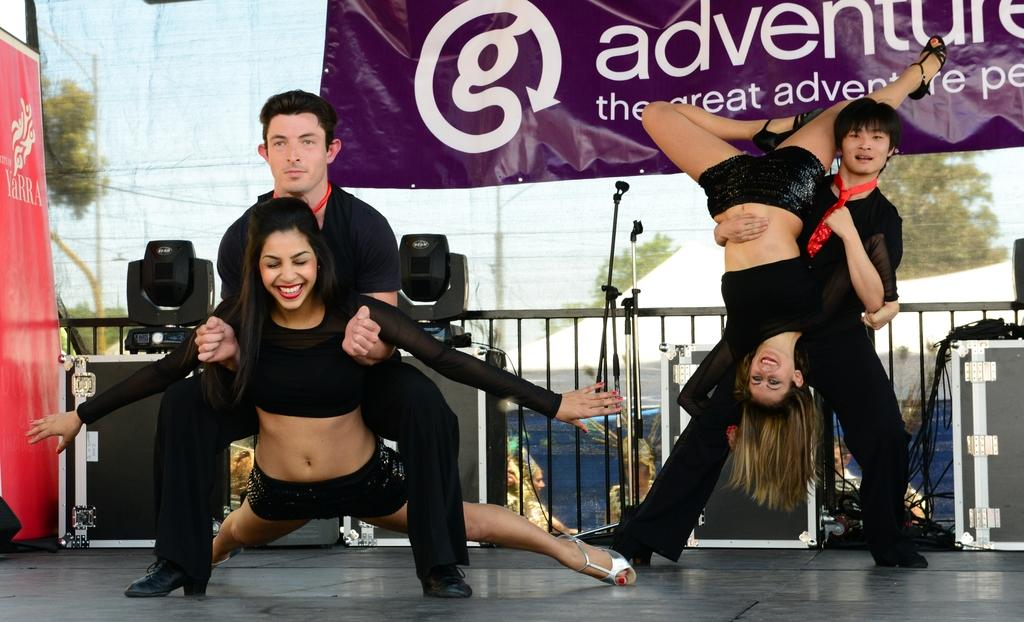What are the people in the image doing? The people in the image are in poses on the surface. What can be seen in the background of the image? In the background of the image, there are banners, railing, boxes, and trees. What structures are present in the image? There is a tent and a pole in the image. What is visible in the sky in the image? The sky is visible in the image. What is the opinion of the body of water in the image? There is no body of water present in the image, so it is not possible to determine its opinion. 